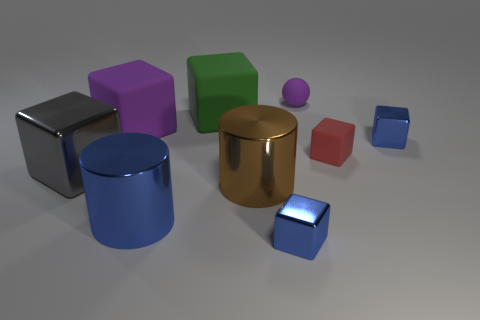Subtract all blue blocks. How many blocks are left? 4 Add 1 big red metal objects. How many objects exist? 10 Subtract all red blocks. How many blocks are left? 5 Subtract all cylinders. How many objects are left? 7 Subtract 1 cylinders. How many cylinders are left? 1 Add 2 large brown things. How many large brown things exist? 3 Subtract 0 cyan blocks. How many objects are left? 9 Subtract all red spheres. Subtract all yellow cylinders. How many spheres are left? 1 Subtract all red blocks. How many brown cylinders are left? 1 Subtract all yellow metallic spheres. Subtract all gray cubes. How many objects are left? 8 